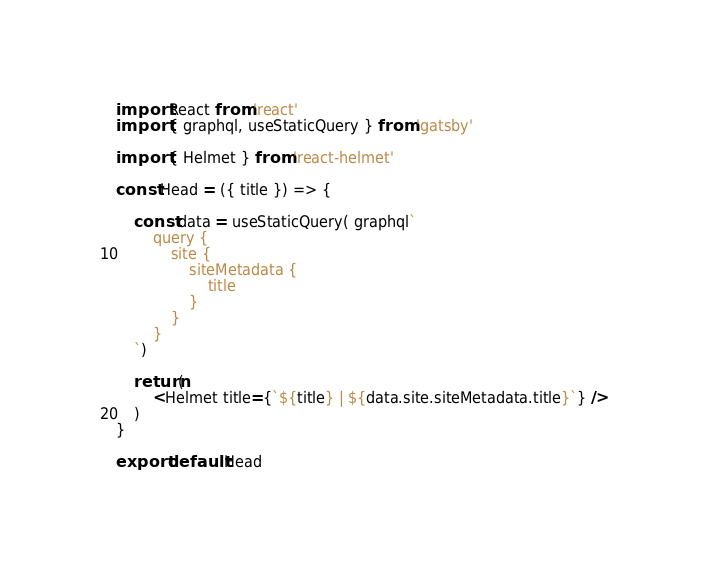Convert code to text. <code><loc_0><loc_0><loc_500><loc_500><_JavaScript_>import React from 'react'
import { graphql, useStaticQuery } from 'gatsby'

import { Helmet } from 'react-helmet'

const Head = ({ title }) => {

    const data = useStaticQuery( graphql`
        query {
            site {
                siteMetadata {
                    title
                }
            }
        }
    `)

    return(
        <Helmet title={`${title} | ${data.site.siteMetadata.title}`} />
    )
}

export default Head</code> 